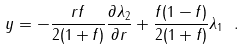Convert formula to latex. <formula><loc_0><loc_0><loc_500><loc_500>y = - \frac { r f } { 2 ( 1 + f ) } \frac { \partial \lambda _ { 2 } } { \partial r } + \frac { f ( 1 - f ) } { 2 ( 1 + f ) } \lambda _ { 1 } \ .</formula> 